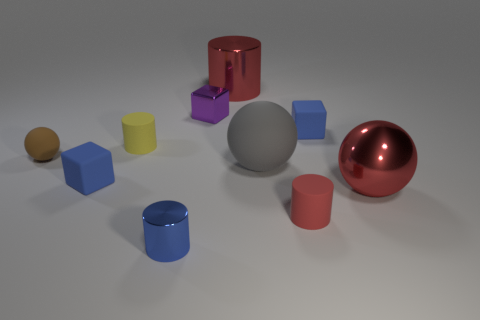Subtract all tiny rubber cubes. How many cubes are left? 1 Subtract all purple cubes. How many cubes are left? 2 Subtract all yellow balls. How many red cubes are left? 0 Subtract 0 cyan cylinders. How many objects are left? 10 Subtract all blocks. How many objects are left? 7 Subtract 2 balls. How many balls are left? 1 Subtract all brown blocks. Subtract all yellow balls. How many blocks are left? 3 Subtract all big cyan matte things. Subtract all blue matte objects. How many objects are left? 8 Add 7 large rubber spheres. How many large rubber spheres are left? 8 Add 3 big gray rubber spheres. How many big gray rubber spheres exist? 4 